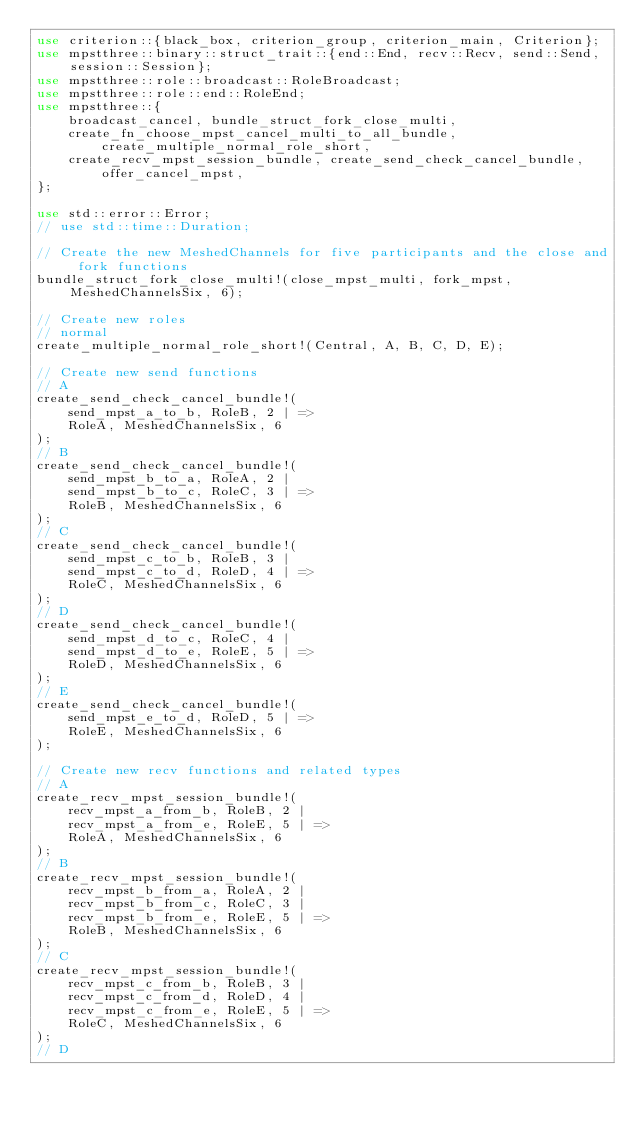<code> <loc_0><loc_0><loc_500><loc_500><_Rust_>use criterion::{black_box, criterion_group, criterion_main, Criterion};
use mpstthree::binary::struct_trait::{end::End, recv::Recv, send::Send, session::Session};
use mpstthree::role::broadcast::RoleBroadcast;
use mpstthree::role::end::RoleEnd;
use mpstthree::{
    broadcast_cancel, bundle_struct_fork_close_multi,
    create_fn_choose_mpst_cancel_multi_to_all_bundle, create_multiple_normal_role_short,
    create_recv_mpst_session_bundle, create_send_check_cancel_bundle, offer_cancel_mpst,
};

use std::error::Error;
// use std::time::Duration;

// Create the new MeshedChannels for five participants and the close and fork functions
bundle_struct_fork_close_multi!(close_mpst_multi, fork_mpst, MeshedChannelsSix, 6);

// Create new roles
// normal
create_multiple_normal_role_short!(Central, A, B, C, D, E);

// Create new send functions
// A
create_send_check_cancel_bundle!(
    send_mpst_a_to_b, RoleB, 2 | =>
    RoleA, MeshedChannelsSix, 6
);
// B
create_send_check_cancel_bundle!(
    send_mpst_b_to_a, RoleA, 2 |
    send_mpst_b_to_c, RoleC, 3 | =>
    RoleB, MeshedChannelsSix, 6
);
// C
create_send_check_cancel_bundle!(
    send_mpst_c_to_b, RoleB, 3 |
    send_mpst_c_to_d, RoleD, 4 | =>
    RoleC, MeshedChannelsSix, 6
);
// D
create_send_check_cancel_bundle!(
    send_mpst_d_to_c, RoleC, 4 |
    send_mpst_d_to_e, RoleE, 5 | =>
    RoleD, MeshedChannelsSix, 6
);
// E
create_send_check_cancel_bundle!(
    send_mpst_e_to_d, RoleD, 5 | =>
    RoleE, MeshedChannelsSix, 6
);

// Create new recv functions and related types
// A
create_recv_mpst_session_bundle!(
    recv_mpst_a_from_b, RoleB, 2 |
    recv_mpst_a_from_e, RoleE, 5 | =>
    RoleA, MeshedChannelsSix, 6
);
// B
create_recv_mpst_session_bundle!(
    recv_mpst_b_from_a, RoleA, 2 |
    recv_mpst_b_from_c, RoleC, 3 |
    recv_mpst_b_from_e, RoleE, 5 | =>
    RoleB, MeshedChannelsSix, 6
);
// C
create_recv_mpst_session_bundle!(
    recv_mpst_c_from_b, RoleB, 3 |
    recv_mpst_c_from_d, RoleD, 4 |
    recv_mpst_c_from_e, RoleE, 5 | =>
    RoleC, MeshedChannelsSix, 6
);
// D</code> 